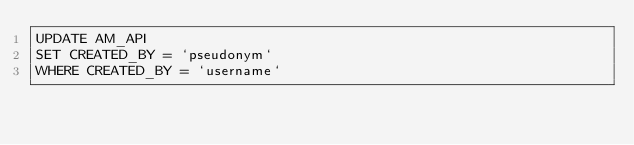Convert code to text. <code><loc_0><loc_0><loc_500><loc_500><_SQL_>UPDATE AM_API
SET CREATED_BY = `pseudonym`
WHERE CREATED_BY = `username`
</code> 